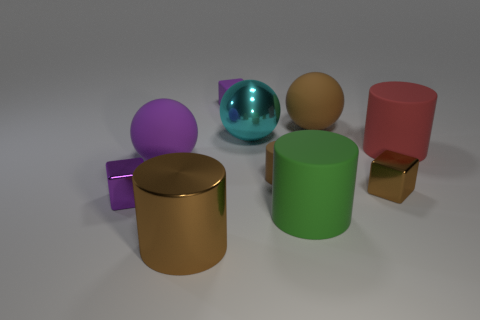What number of large purple objects are the same shape as the big cyan thing?
Ensure brevity in your answer.  1. Does the large green thing have the same shape as the large red object?
Your response must be concise. Yes. What number of things are either purple objects behind the cyan metallic ball or large blue blocks?
Provide a short and direct response. 1. What is the shape of the small rubber thing that is in front of the tiny purple object right of the purple cube that is in front of the rubber block?
Offer a very short reply. Cylinder. There is a large red thing that is made of the same material as the large green thing; what shape is it?
Your answer should be compact. Cylinder. The purple rubber block is what size?
Make the answer very short. Small. Do the green matte thing and the purple metallic block have the same size?
Keep it short and to the point. No. What number of objects are either purple blocks that are in front of the large brown rubber sphere or tiny brown objects that are behind the green matte object?
Offer a very short reply. 3. There is a large brown object right of the tiny matte thing that is in front of the big brown rubber thing; what number of large red objects are to the left of it?
Offer a very short reply. 0. There is a brown metal thing that is to the right of the large metal cylinder; what is its size?
Your answer should be very brief. Small. 